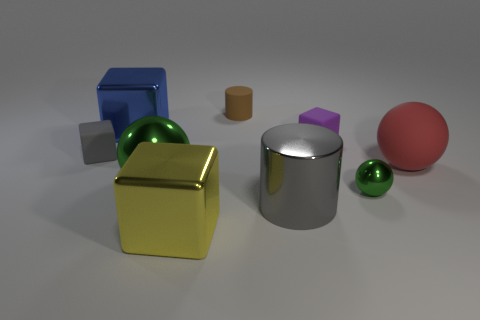Add 1 yellow things. How many objects exist? 10 Subtract all green cubes. Subtract all yellow cylinders. How many cubes are left? 4 Subtract all cylinders. How many objects are left? 7 Subtract all green spheres. Subtract all big gray cylinders. How many objects are left? 6 Add 3 big gray objects. How many big gray objects are left? 4 Add 2 gray metal cubes. How many gray metal cubes exist? 2 Subtract 1 green balls. How many objects are left? 8 